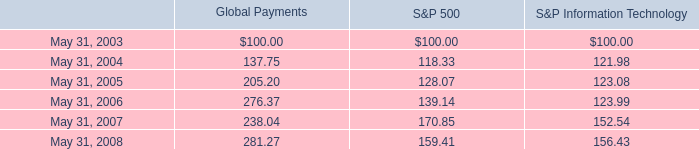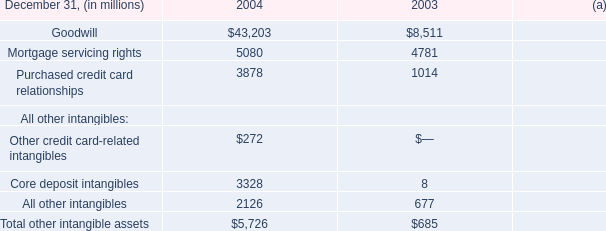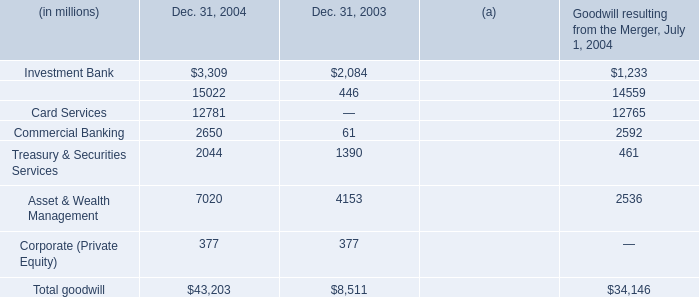in a slight recession of the overall market , what percentage did the stock price of global payments change? 
Computations: (281.27 - 238.04)
Answer: 43.23. 